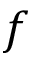Convert formula to latex. <formula><loc_0><loc_0><loc_500><loc_500>f</formula> 